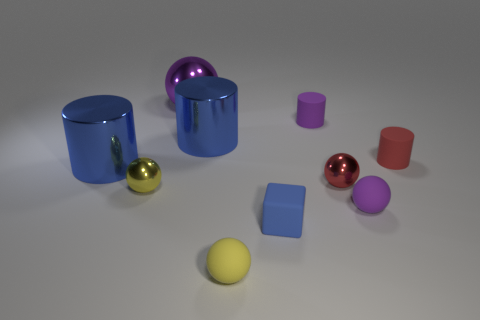Subtract all tiny red matte cylinders. How many cylinders are left? 3 Subtract all purple cylinders. How many cylinders are left? 3 Subtract all cubes. How many objects are left? 9 Subtract 0 gray cubes. How many objects are left? 10 Subtract 1 cubes. How many cubes are left? 0 Subtract all brown balls. Subtract all green cylinders. How many balls are left? 5 Subtract all blue cylinders. How many purple spheres are left? 2 Subtract all tiny cyan objects. Subtract all yellow things. How many objects are left? 8 Add 9 blue cubes. How many blue cubes are left? 10 Add 1 small blue rubber blocks. How many small blue rubber blocks exist? 2 